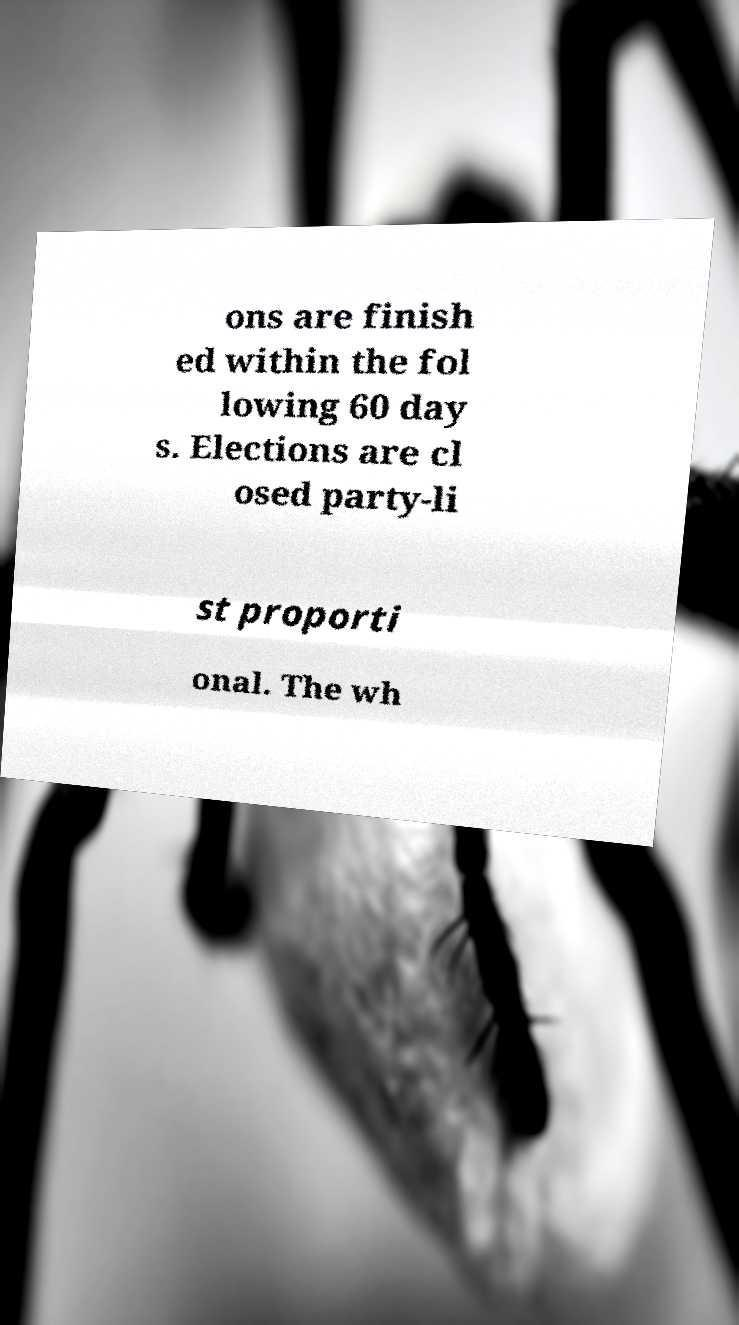Could you extract and type out the text from this image? ons are finish ed within the fol lowing 60 day s. Elections are cl osed party-li st proporti onal. The wh 